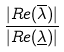Convert formula to latex. <formula><loc_0><loc_0><loc_500><loc_500>\frac { | R e ( \overline { \lambda } ) | } { | R e ( \underline { \lambda } ) | }</formula> 